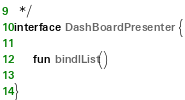Convert code to text. <code><loc_0><loc_0><loc_500><loc_500><_Kotlin_> */
interface DashBoardPresenter {

    fun bindlList()

}</code> 